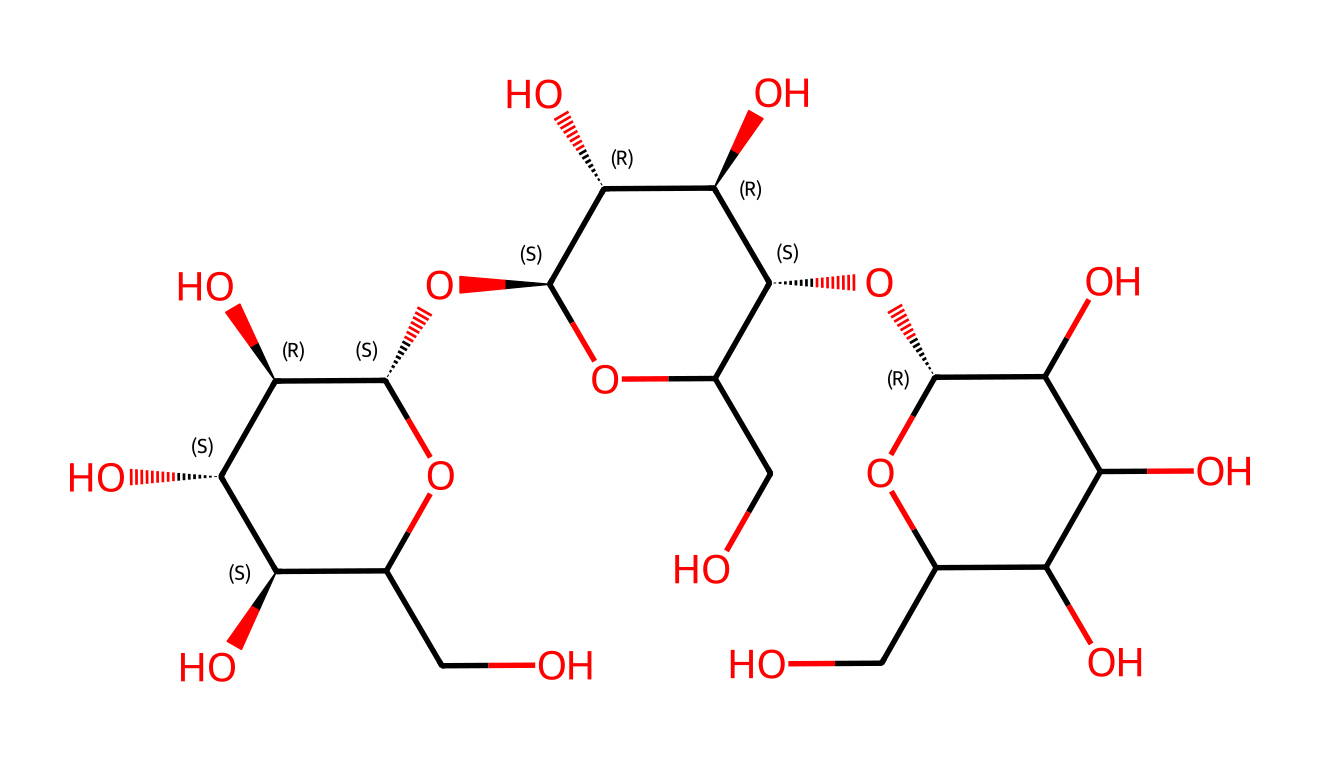What is the main type of polysaccharide found in this chemical? This chemical structure represents cellulose, which is a polysaccharide made up of glucose units. The repetitive units are linked by β(1→4) glycosidic bonds.
Answer: cellulose How many hydroxyl (OH) groups are present in this structure? By analyzing the chemical structure, we can identify that the molecule has several hydroxyl (OH) groups. There are a total of six OH groups in this specific structure.
Answer: six What is the significance of the β(1→4) glycosidic linkage in cellulose fibers? The β(1→4) glycosidic linkage is crucial because it provides cellulose with its unique structural properties, allowing the fibers to form strong and rigid structures, which is essential for the mechanical strength of cotton.
Answer: strength Which part of the chemical allows it to absorb water? The presence of multiple hydroxyl (OH) groups in the cellulose structure allows it to form hydrogen bonds with water molecules, leading to its excellent water absorption properties.
Answer: hydroxyl groups How does the branching of the cellulose structure affect its properties? In this structural representation, cellulose has little to no branching, which contributes to its rigid and linear chains. This linearity is essential in forming strong hydrogen bonds between chains, enhancing its tensile strength.
Answer: rigidity 